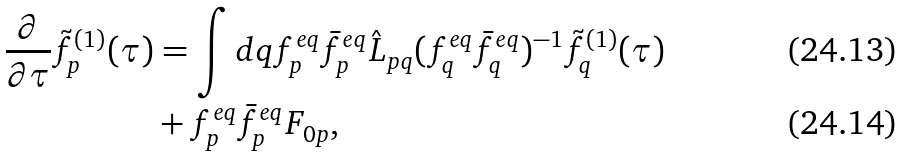<formula> <loc_0><loc_0><loc_500><loc_500>\frac { \partial } { \partial \tau } \tilde { f } ^ { ( 1 ) } _ { p } ( \tau ) & = \int d q f ^ { e q } _ { p } \bar { f } ^ { e q } _ { p } \hat { L } _ { p q } ( f ^ { e q } _ { q } \bar { f } ^ { e q } _ { q } ) ^ { - 1 } \tilde { f } ^ { ( 1 ) } _ { q } ( \tau ) \\ & + f ^ { e q } _ { p } \bar { f } ^ { e q } _ { p } F _ { 0 p } ,</formula> 